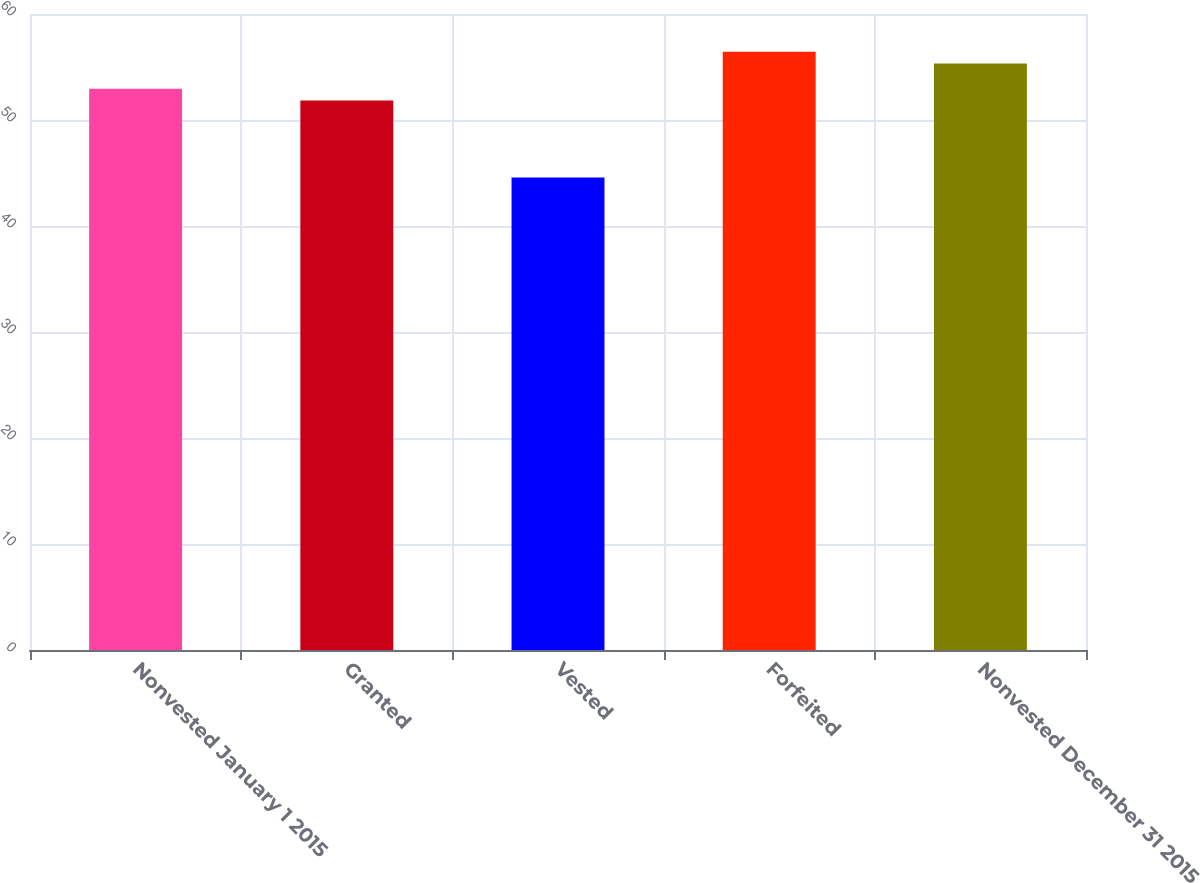Convert chart to OTSL. <chart><loc_0><loc_0><loc_500><loc_500><bar_chart><fcel>Nonvested January 1 2015<fcel>Granted<fcel>Vested<fcel>Forfeited<fcel>Nonvested December 31 2015<nl><fcel>52.95<fcel>51.84<fcel>44.58<fcel>56.44<fcel>55.33<nl></chart> 